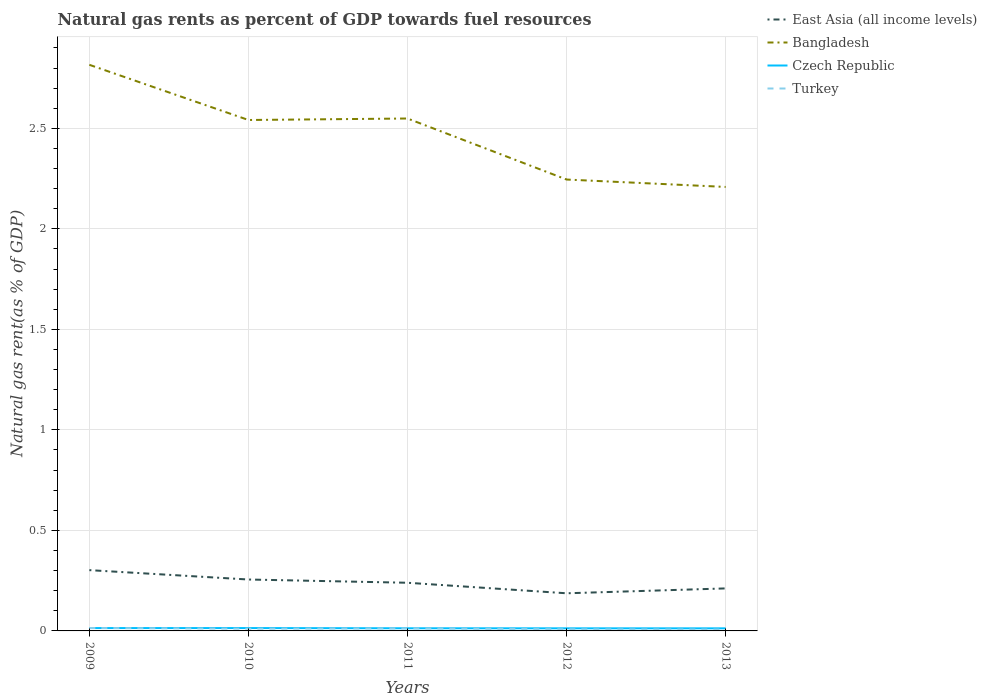Does the line corresponding to Turkey intersect with the line corresponding to Czech Republic?
Ensure brevity in your answer.  Yes. Across all years, what is the maximum natural gas rent in East Asia (all income levels)?
Make the answer very short. 0.19. In which year was the natural gas rent in East Asia (all income levels) maximum?
Your answer should be compact. 2012. What is the total natural gas rent in Czech Republic in the graph?
Ensure brevity in your answer.  0. What is the difference between the highest and the second highest natural gas rent in Bangladesh?
Provide a succinct answer. 0.61. What is the difference between the highest and the lowest natural gas rent in East Asia (all income levels)?
Provide a short and direct response. 3. Is the natural gas rent in Bangladesh strictly greater than the natural gas rent in East Asia (all income levels) over the years?
Your answer should be compact. No. What is the difference between two consecutive major ticks on the Y-axis?
Your answer should be compact. 0.5. Are the values on the major ticks of Y-axis written in scientific E-notation?
Give a very brief answer. No. How are the legend labels stacked?
Offer a terse response. Vertical. What is the title of the graph?
Make the answer very short. Natural gas rents as percent of GDP towards fuel resources. Does "Guinea" appear as one of the legend labels in the graph?
Offer a terse response. No. What is the label or title of the Y-axis?
Provide a succinct answer. Natural gas rent(as % of GDP). What is the Natural gas rent(as % of GDP) of East Asia (all income levels) in 2009?
Make the answer very short. 0.3. What is the Natural gas rent(as % of GDP) in Bangladesh in 2009?
Provide a succinct answer. 2.82. What is the Natural gas rent(as % of GDP) in Czech Republic in 2009?
Make the answer very short. 0.01. What is the Natural gas rent(as % of GDP) of Turkey in 2009?
Your answer should be compact. 0.01. What is the Natural gas rent(as % of GDP) of East Asia (all income levels) in 2010?
Give a very brief answer. 0.26. What is the Natural gas rent(as % of GDP) in Bangladesh in 2010?
Provide a short and direct response. 2.54. What is the Natural gas rent(as % of GDP) of Czech Republic in 2010?
Keep it short and to the point. 0.01. What is the Natural gas rent(as % of GDP) in Turkey in 2010?
Provide a short and direct response. 0.01. What is the Natural gas rent(as % of GDP) in East Asia (all income levels) in 2011?
Offer a very short reply. 0.24. What is the Natural gas rent(as % of GDP) of Bangladesh in 2011?
Give a very brief answer. 2.55. What is the Natural gas rent(as % of GDP) in Czech Republic in 2011?
Keep it short and to the point. 0.01. What is the Natural gas rent(as % of GDP) in Turkey in 2011?
Your response must be concise. 0.01. What is the Natural gas rent(as % of GDP) in East Asia (all income levels) in 2012?
Offer a terse response. 0.19. What is the Natural gas rent(as % of GDP) of Bangladesh in 2012?
Keep it short and to the point. 2.25. What is the Natural gas rent(as % of GDP) in Czech Republic in 2012?
Provide a short and direct response. 0.01. What is the Natural gas rent(as % of GDP) in Turkey in 2012?
Your response must be concise. 0.01. What is the Natural gas rent(as % of GDP) of East Asia (all income levels) in 2013?
Provide a short and direct response. 0.21. What is the Natural gas rent(as % of GDP) in Bangladesh in 2013?
Keep it short and to the point. 2.21. What is the Natural gas rent(as % of GDP) of Czech Republic in 2013?
Your answer should be compact. 0.01. What is the Natural gas rent(as % of GDP) of Turkey in 2013?
Provide a succinct answer. 0.01. Across all years, what is the maximum Natural gas rent(as % of GDP) in East Asia (all income levels)?
Keep it short and to the point. 0.3. Across all years, what is the maximum Natural gas rent(as % of GDP) of Bangladesh?
Your answer should be compact. 2.82. Across all years, what is the maximum Natural gas rent(as % of GDP) of Czech Republic?
Your answer should be very brief. 0.01. Across all years, what is the maximum Natural gas rent(as % of GDP) in Turkey?
Make the answer very short. 0.01. Across all years, what is the minimum Natural gas rent(as % of GDP) of East Asia (all income levels)?
Give a very brief answer. 0.19. Across all years, what is the minimum Natural gas rent(as % of GDP) of Bangladesh?
Provide a short and direct response. 2.21. Across all years, what is the minimum Natural gas rent(as % of GDP) of Czech Republic?
Provide a short and direct response. 0.01. Across all years, what is the minimum Natural gas rent(as % of GDP) in Turkey?
Keep it short and to the point. 0.01. What is the total Natural gas rent(as % of GDP) of East Asia (all income levels) in the graph?
Your response must be concise. 1.2. What is the total Natural gas rent(as % of GDP) of Bangladesh in the graph?
Provide a succinct answer. 12.36. What is the total Natural gas rent(as % of GDP) in Czech Republic in the graph?
Offer a very short reply. 0.07. What is the total Natural gas rent(as % of GDP) of Turkey in the graph?
Offer a terse response. 0.05. What is the difference between the Natural gas rent(as % of GDP) of East Asia (all income levels) in 2009 and that in 2010?
Keep it short and to the point. 0.05. What is the difference between the Natural gas rent(as % of GDP) in Bangladesh in 2009 and that in 2010?
Make the answer very short. 0.27. What is the difference between the Natural gas rent(as % of GDP) of Czech Republic in 2009 and that in 2010?
Your answer should be compact. -0. What is the difference between the Natural gas rent(as % of GDP) of Turkey in 2009 and that in 2010?
Offer a very short reply. 0. What is the difference between the Natural gas rent(as % of GDP) in East Asia (all income levels) in 2009 and that in 2011?
Your answer should be very brief. 0.06. What is the difference between the Natural gas rent(as % of GDP) in Bangladesh in 2009 and that in 2011?
Ensure brevity in your answer.  0.27. What is the difference between the Natural gas rent(as % of GDP) in Turkey in 2009 and that in 2011?
Provide a succinct answer. 0. What is the difference between the Natural gas rent(as % of GDP) of East Asia (all income levels) in 2009 and that in 2012?
Give a very brief answer. 0.12. What is the difference between the Natural gas rent(as % of GDP) of Bangladesh in 2009 and that in 2012?
Keep it short and to the point. 0.57. What is the difference between the Natural gas rent(as % of GDP) of Czech Republic in 2009 and that in 2012?
Offer a very short reply. 0. What is the difference between the Natural gas rent(as % of GDP) in Turkey in 2009 and that in 2012?
Your answer should be very brief. 0.01. What is the difference between the Natural gas rent(as % of GDP) of East Asia (all income levels) in 2009 and that in 2013?
Keep it short and to the point. 0.09. What is the difference between the Natural gas rent(as % of GDP) of Bangladesh in 2009 and that in 2013?
Give a very brief answer. 0.61. What is the difference between the Natural gas rent(as % of GDP) of Czech Republic in 2009 and that in 2013?
Ensure brevity in your answer.  0. What is the difference between the Natural gas rent(as % of GDP) in Turkey in 2009 and that in 2013?
Your response must be concise. 0.01. What is the difference between the Natural gas rent(as % of GDP) in East Asia (all income levels) in 2010 and that in 2011?
Your answer should be very brief. 0.02. What is the difference between the Natural gas rent(as % of GDP) in Bangladesh in 2010 and that in 2011?
Offer a terse response. -0.01. What is the difference between the Natural gas rent(as % of GDP) in Turkey in 2010 and that in 2011?
Offer a very short reply. -0. What is the difference between the Natural gas rent(as % of GDP) in East Asia (all income levels) in 2010 and that in 2012?
Keep it short and to the point. 0.07. What is the difference between the Natural gas rent(as % of GDP) of Bangladesh in 2010 and that in 2012?
Provide a succinct answer. 0.3. What is the difference between the Natural gas rent(as % of GDP) of Czech Republic in 2010 and that in 2012?
Your response must be concise. 0. What is the difference between the Natural gas rent(as % of GDP) in Turkey in 2010 and that in 2012?
Your response must be concise. 0. What is the difference between the Natural gas rent(as % of GDP) in East Asia (all income levels) in 2010 and that in 2013?
Your response must be concise. 0.04. What is the difference between the Natural gas rent(as % of GDP) of Bangladesh in 2010 and that in 2013?
Offer a terse response. 0.33. What is the difference between the Natural gas rent(as % of GDP) of Czech Republic in 2010 and that in 2013?
Your answer should be very brief. 0. What is the difference between the Natural gas rent(as % of GDP) of Turkey in 2010 and that in 2013?
Make the answer very short. 0. What is the difference between the Natural gas rent(as % of GDP) in East Asia (all income levels) in 2011 and that in 2012?
Your answer should be very brief. 0.05. What is the difference between the Natural gas rent(as % of GDP) in Bangladesh in 2011 and that in 2012?
Your answer should be compact. 0.3. What is the difference between the Natural gas rent(as % of GDP) of Turkey in 2011 and that in 2012?
Offer a terse response. 0. What is the difference between the Natural gas rent(as % of GDP) of East Asia (all income levels) in 2011 and that in 2013?
Make the answer very short. 0.03. What is the difference between the Natural gas rent(as % of GDP) in Bangladesh in 2011 and that in 2013?
Make the answer very short. 0.34. What is the difference between the Natural gas rent(as % of GDP) in Czech Republic in 2011 and that in 2013?
Make the answer very short. 0. What is the difference between the Natural gas rent(as % of GDP) in Turkey in 2011 and that in 2013?
Provide a short and direct response. 0.01. What is the difference between the Natural gas rent(as % of GDP) in East Asia (all income levels) in 2012 and that in 2013?
Your answer should be compact. -0.02. What is the difference between the Natural gas rent(as % of GDP) of Bangladesh in 2012 and that in 2013?
Offer a very short reply. 0.04. What is the difference between the Natural gas rent(as % of GDP) of Czech Republic in 2012 and that in 2013?
Keep it short and to the point. 0. What is the difference between the Natural gas rent(as % of GDP) in Turkey in 2012 and that in 2013?
Provide a succinct answer. 0. What is the difference between the Natural gas rent(as % of GDP) in East Asia (all income levels) in 2009 and the Natural gas rent(as % of GDP) in Bangladesh in 2010?
Ensure brevity in your answer.  -2.24. What is the difference between the Natural gas rent(as % of GDP) of East Asia (all income levels) in 2009 and the Natural gas rent(as % of GDP) of Czech Republic in 2010?
Your answer should be very brief. 0.29. What is the difference between the Natural gas rent(as % of GDP) of East Asia (all income levels) in 2009 and the Natural gas rent(as % of GDP) of Turkey in 2010?
Offer a very short reply. 0.29. What is the difference between the Natural gas rent(as % of GDP) in Bangladesh in 2009 and the Natural gas rent(as % of GDP) in Czech Republic in 2010?
Ensure brevity in your answer.  2.8. What is the difference between the Natural gas rent(as % of GDP) in Bangladesh in 2009 and the Natural gas rent(as % of GDP) in Turkey in 2010?
Keep it short and to the point. 2.81. What is the difference between the Natural gas rent(as % of GDP) in Czech Republic in 2009 and the Natural gas rent(as % of GDP) in Turkey in 2010?
Your answer should be very brief. 0. What is the difference between the Natural gas rent(as % of GDP) of East Asia (all income levels) in 2009 and the Natural gas rent(as % of GDP) of Bangladesh in 2011?
Offer a very short reply. -2.25. What is the difference between the Natural gas rent(as % of GDP) in East Asia (all income levels) in 2009 and the Natural gas rent(as % of GDP) in Czech Republic in 2011?
Your answer should be very brief. 0.29. What is the difference between the Natural gas rent(as % of GDP) of East Asia (all income levels) in 2009 and the Natural gas rent(as % of GDP) of Turkey in 2011?
Your answer should be very brief. 0.29. What is the difference between the Natural gas rent(as % of GDP) of Bangladesh in 2009 and the Natural gas rent(as % of GDP) of Czech Republic in 2011?
Give a very brief answer. 2.8. What is the difference between the Natural gas rent(as % of GDP) of Bangladesh in 2009 and the Natural gas rent(as % of GDP) of Turkey in 2011?
Offer a very short reply. 2.8. What is the difference between the Natural gas rent(as % of GDP) of Czech Republic in 2009 and the Natural gas rent(as % of GDP) of Turkey in 2011?
Keep it short and to the point. 0. What is the difference between the Natural gas rent(as % of GDP) in East Asia (all income levels) in 2009 and the Natural gas rent(as % of GDP) in Bangladesh in 2012?
Provide a succinct answer. -1.94. What is the difference between the Natural gas rent(as % of GDP) in East Asia (all income levels) in 2009 and the Natural gas rent(as % of GDP) in Czech Republic in 2012?
Provide a short and direct response. 0.29. What is the difference between the Natural gas rent(as % of GDP) of East Asia (all income levels) in 2009 and the Natural gas rent(as % of GDP) of Turkey in 2012?
Your answer should be very brief. 0.29. What is the difference between the Natural gas rent(as % of GDP) of Bangladesh in 2009 and the Natural gas rent(as % of GDP) of Czech Republic in 2012?
Your answer should be very brief. 2.8. What is the difference between the Natural gas rent(as % of GDP) in Bangladesh in 2009 and the Natural gas rent(as % of GDP) in Turkey in 2012?
Make the answer very short. 2.81. What is the difference between the Natural gas rent(as % of GDP) in Czech Republic in 2009 and the Natural gas rent(as % of GDP) in Turkey in 2012?
Provide a succinct answer. 0.01. What is the difference between the Natural gas rent(as % of GDP) in East Asia (all income levels) in 2009 and the Natural gas rent(as % of GDP) in Bangladesh in 2013?
Provide a succinct answer. -1.91. What is the difference between the Natural gas rent(as % of GDP) in East Asia (all income levels) in 2009 and the Natural gas rent(as % of GDP) in Czech Republic in 2013?
Provide a short and direct response. 0.29. What is the difference between the Natural gas rent(as % of GDP) of East Asia (all income levels) in 2009 and the Natural gas rent(as % of GDP) of Turkey in 2013?
Provide a short and direct response. 0.3. What is the difference between the Natural gas rent(as % of GDP) in Bangladesh in 2009 and the Natural gas rent(as % of GDP) in Czech Republic in 2013?
Your response must be concise. 2.8. What is the difference between the Natural gas rent(as % of GDP) in Bangladesh in 2009 and the Natural gas rent(as % of GDP) in Turkey in 2013?
Ensure brevity in your answer.  2.81. What is the difference between the Natural gas rent(as % of GDP) in Czech Republic in 2009 and the Natural gas rent(as % of GDP) in Turkey in 2013?
Make the answer very short. 0.01. What is the difference between the Natural gas rent(as % of GDP) of East Asia (all income levels) in 2010 and the Natural gas rent(as % of GDP) of Bangladesh in 2011?
Give a very brief answer. -2.29. What is the difference between the Natural gas rent(as % of GDP) in East Asia (all income levels) in 2010 and the Natural gas rent(as % of GDP) in Czech Republic in 2011?
Provide a succinct answer. 0.24. What is the difference between the Natural gas rent(as % of GDP) of East Asia (all income levels) in 2010 and the Natural gas rent(as % of GDP) of Turkey in 2011?
Your answer should be very brief. 0.24. What is the difference between the Natural gas rent(as % of GDP) in Bangladesh in 2010 and the Natural gas rent(as % of GDP) in Czech Republic in 2011?
Offer a terse response. 2.53. What is the difference between the Natural gas rent(as % of GDP) in Bangladesh in 2010 and the Natural gas rent(as % of GDP) in Turkey in 2011?
Ensure brevity in your answer.  2.53. What is the difference between the Natural gas rent(as % of GDP) of Czech Republic in 2010 and the Natural gas rent(as % of GDP) of Turkey in 2011?
Offer a terse response. 0. What is the difference between the Natural gas rent(as % of GDP) in East Asia (all income levels) in 2010 and the Natural gas rent(as % of GDP) in Bangladesh in 2012?
Offer a terse response. -1.99. What is the difference between the Natural gas rent(as % of GDP) of East Asia (all income levels) in 2010 and the Natural gas rent(as % of GDP) of Czech Republic in 2012?
Offer a terse response. 0.24. What is the difference between the Natural gas rent(as % of GDP) in East Asia (all income levels) in 2010 and the Natural gas rent(as % of GDP) in Turkey in 2012?
Make the answer very short. 0.25. What is the difference between the Natural gas rent(as % of GDP) in Bangladesh in 2010 and the Natural gas rent(as % of GDP) in Czech Republic in 2012?
Offer a terse response. 2.53. What is the difference between the Natural gas rent(as % of GDP) of Bangladesh in 2010 and the Natural gas rent(as % of GDP) of Turkey in 2012?
Keep it short and to the point. 2.53. What is the difference between the Natural gas rent(as % of GDP) of Czech Republic in 2010 and the Natural gas rent(as % of GDP) of Turkey in 2012?
Offer a very short reply. 0.01. What is the difference between the Natural gas rent(as % of GDP) in East Asia (all income levels) in 2010 and the Natural gas rent(as % of GDP) in Bangladesh in 2013?
Offer a terse response. -1.95. What is the difference between the Natural gas rent(as % of GDP) of East Asia (all income levels) in 2010 and the Natural gas rent(as % of GDP) of Czech Republic in 2013?
Make the answer very short. 0.24. What is the difference between the Natural gas rent(as % of GDP) in East Asia (all income levels) in 2010 and the Natural gas rent(as % of GDP) in Turkey in 2013?
Your response must be concise. 0.25. What is the difference between the Natural gas rent(as % of GDP) of Bangladesh in 2010 and the Natural gas rent(as % of GDP) of Czech Republic in 2013?
Your answer should be very brief. 2.53. What is the difference between the Natural gas rent(as % of GDP) of Bangladesh in 2010 and the Natural gas rent(as % of GDP) of Turkey in 2013?
Offer a very short reply. 2.53. What is the difference between the Natural gas rent(as % of GDP) in Czech Republic in 2010 and the Natural gas rent(as % of GDP) in Turkey in 2013?
Provide a short and direct response. 0.01. What is the difference between the Natural gas rent(as % of GDP) in East Asia (all income levels) in 2011 and the Natural gas rent(as % of GDP) in Bangladesh in 2012?
Make the answer very short. -2.01. What is the difference between the Natural gas rent(as % of GDP) of East Asia (all income levels) in 2011 and the Natural gas rent(as % of GDP) of Czech Republic in 2012?
Offer a terse response. 0.23. What is the difference between the Natural gas rent(as % of GDP) in East Asia (all income levels) in 2011 and the Natural gas rent(as % of GDP) in Turkey in 2012?
Keep it short and to the point. 0.23. What is the difference between the Natural gas rent(as % of GDP) in Bangladesh in 2011 and the Natural gas rent(as % of GDP) in Czech Republic in 2012?
Offer a very short reply. 2.54. What is the difference between the Natural gas rent(as % of GDP) in Bangladesh in 2011 and the Natural gas rent(as % of GDP) in Turkey in 2012?
Provide a short and direct response. 2.54. What is the difference between the Natural gas rent(as % of GDP) in Czech Republic in 2011 and the Natural gas rent(as % of GDP) in Turkey in 2012?
Your answer should be compact. 0.01. What is the difference between the Natural gas rent(as % of GDP) of East Asia (all income levels) in 2011 and the Natural gas rent(as % of GDP) of Bangladesh in 2013?
Provide a short and direct response. -1.97. What is the difference between the Natural gas rent(as % of GDP) of East Asia (all income levels) in 2011 and the Natural gas rent(as % of GDP) of Czech Republic in 2013?
Ensure brevity in your answer.  0.23. What is the difference between the Natural gas rent(as % of GDP) in East Asia (all income levels) in 2011 and the Natural gas rent(as % of GDP) in Turkey in 2013?
Give a very brief answer. 0.23. What is the difference between the Natural gas rent(as % of GDP) in Bangladesh in 2011 and the Natural gas rent(as % of GDP) in Czech Republic in 2013?
Your answer should be very brief. 2.54. What is the difference between the Natural gas rent(as % of GDP) in Bangladesh in 2011 and the Natural gas rent(as % of GDP) in Turkey in 2013?
Offer a very short reply. 2.54. What is the difference between the Natural gas rent(as % of GDP) of Czech Republic in 2011 and the Natural gas rent(as % of GDP) of Turkey in 2013?
Make the answer very short. 0.01. What is the difference between the Natural gas rent(as % of GDP) in East Asia (all income levels) in 2012 and the Natural gas rent(as % of GDP) in Bangladesh in 2013?
Your answer should be compact. -2.02. What is the difference between the Natural gas rent(as % of GDP) in East Asia (all income levels) in 2012 and the Natural gas rent(as % of GDP) in Czech Republic in 2013?
Provide a short and direct response. 0.17. What is the difference between the Natural gas rent(as % of GDP) of East Asia (all income levels) in 2012 and the Natural gas rent(as % of GDP) of Turkey in 2013?
Keep it short and to the point. 0.18. What is the difference between the Natural gas rent(as % of GDP) in Bangladesh in 2012 and the Natural gas rent(as % of GDP) in Czech Republic in 2013?
Provide a succinct answer. 2.23. What is the difference between the Natural gas rent(as % of GDP) of Bangladesh in 2012 and the Natural gas rent(as % of GDP) of Turkey in 2013?
Offer a terse response. 2.24. What is the difference between the Natural gas rent(as % of GDP) in Czech Republic in 2012 and the Natural gas rent(as % of GDP) in Turkey in 2013?
Your response must be concise. 0.01. What is the average Natural gas rent(as % of GDP) of East Asia (all income levels) per year?
Make the answer very short. 0.24. What is the average Natural gas rent(as % of GDP) in Bangladesh per year?
Offer a terse response. 2.47. What is the average Natural gas rent(as % of GDP) of Czech Republic per year?
Offer a terse response. 0.01. What is the average Natural gas rent(as % of GDP) of Turkey per year?
Your response must be concise. 0.01. In the year 2009, what is the difference between the Natural gas rent(as % of GDP) of East Asia (all income levels) and Natural gas rent(as % of GDP) of Bangladesh?
Your answer should be compact. -2.51. In the year 2009, what is the difference between the Natural gas rent(as % of GDP) of East Asia (all income levels) and Natural gas rent(as % of GDP) of Czech Republic?
Your answer should be compact. 0.29. In the year 2009, what is the difference between the Natural gas rent(as % of GDP) in East Asia (all income levels) and Natural gas rent(as % of GDP) in Turkey?
Offer a very short reply. 0.29. In the year 2009, what is the difference between the Natural gas rent(as % of GDP) of Bangladesh and Natural gas rent(as % of GDP) of Czech Republic?
Offer a terse response. 2.8. In the year 2009, what is the difference between the Natural gas rent(as % of GDP) of Bangladesh and Natural gas rent(as % of GDP) of Turkey?
Provide a succinct answer. 2.8. In the year 2009, what is the difference between the Natural gas rent(as % of GDP) of Czech Republic and Natural gas rent(as % of GDP) of Turkey?
Offer a terse response. -0. In the year 2010, what is the difference between the Natural gas rent(as % of GDP) of East Asia (all income levels) and Natural gas rent(as % of GDP) of Bangladesh?
Your response must be concise. -2.29. In the year 2010, what is the difference between the Natural gas rent(as % of GDP) of East Asia (all income levels) and Natural gas rent(as % of GDP) of Czech Republic?
Ensure brevity in your answer.  0.24. In the year 2010, what is the difference between the Natural gas rent(as % of GDP) of East Asia (all income levels) and Natural gas rent(as % of GDP) of Turkey?
Your answer should be very brief. 0.24. In the year 2010, what is the difference between the Natural gas rent(as % of GDP) in Bangladesh and Natural gas rent(as % of GDP) in Czech Republic?
Make the answer very short. 2.53. In the year 2010, what is the difference between the Natural gas rent(as % of GDP) of Bangladesh and Natural gas rent(as % of GDP) of Turkey?
Your answer should be very brief. 2.53. In the year 2010, what is the difference between the Natural gas rent(as % of GDP) of Czech Republic and Natural gas rent(as % of GDP) of Turkey?
Offer a terse response. 0. In the year 2011, what is the difference between the Natural gas rent(as % of GDP) in East Asia (all income levels) and Natural gas rent(as % of GDP) in Bangladesh?
Provide a short and direct response. -2.31. In the year 2011, what is the difference between the Natural gas rent(as % of GDP) of East Asia (all income levels) and Natural gas rent(as % of GDP) of Czech Republic?
Give a very brief answer. 0.23. In the year 2011, what is the difference between the Natural gas rent(as % of GDP) of East Asia (all income levels) and Natural gas rent(as % of GDP) of Turkey?
Provide a succinct answer. 0.23. In the year 2011, what is the difference between the Natural gas rent(as % of GDP) of Bangladesh and Natural gas rent(as % of GDP) of Czech Republic?
Provide a short and direct response. 2.54. In the year 2011, what is the difference between the Natural gas rent(as % of GDP) of Bangladesh and Natural gas rent(as % of GDP) of Turkey?
Offer a very short reply. 2.54. In the year 2011, what is the difference between the Natural gas rent(as % of GDP) in Czech Republic and Natural gas rent(as % of GDP) in Turkey?
Keep it short and to the point. 0. In the year 2012, what is the difference between the Natural gas rent(as % of GDP) of East Asia (all income levels) and Natural gas rent(as % of GDP) of Bangladesh?
Provide a short and direct response. -2.06. In the year 2012, what is the difference between the Natural gas rent(as % of GDP) of East Asia (all income levels) and Natural gas rent(as % of GDP) of Czech Republic?
Your answer should be very brief. 0.17. In the year 2012, what is the difference between the Natural gas rent(as % of GDP) in East Asia (all income levels) and Natural gas rent(as % of GDP) in Turkey?
Your response must be concise. 0.18. In the year 2012, what is the difference between the Natural gas rent(as % of GDP) of Bangladesh and Natural gas rent(as % of GDP) of Czech Republic?
Give a very brief answer. 2.23. In the year 2012, what is the difference between the Natural gas rent(as % of GDP) in Bangladesh and Natural gas rent(as % of GDP) in Turkey?
Your answer should be very brief. 2.24. In the year 2012, what is the difference between the Natural gas rent(as % of GDP) in Czech Republic and Natural gas rent(as % of GDP) in Turkey?
Provide a short and direct response. 0. In the year 2013, what is the difference between the Natural gas rent(as % of GDP) in East Asia (all income levels) and Natural gas rent(as % of GDP) in Bangladesh?
Provide a short and direct response. -2. In the year 2013, what is the difference between the Natural gas rent(as % of GDP) in East Asia (all income levels) and Natural gas rent(as % of GDP) in Czech Republic?
Provide a short and direct response. 0.2. In the year 2013, what is the difference between the Natural gas rent(as % of GDP) in East Asia (all income levels) and Natural gas rent(as % of GDP) in Turkey?
Offer a terse response. 0.2. In the year 2013, what is the difference between the Natural gas rent(as % of GDP) in Bangladesh and Natural gas rent(as % of GDP) in Czech Republic?
Ensure brevity in your answer.  2.2. In the year 2013, what is the difference between the Natural gas rent(as % of GDP) in Bangladesh and Natural gas rent(as % of GDP) in Turkey?
Your answer should be compact. 2.2. In the year 2013, what is the difference between the Natural gas rent(as % of GDP) of Czech Republic and Natural gas rent(as % of GDP) of Turkey?
Give a very brief answer. 0.01. What is the ratio of the Natural gas rent(as % of GDP) in East Asia (all income levels) in 2009 to that in 2010?
Your answer should be very brief. 1.18. What is the ratio of the Natural gas rent(as % of GDP) of Bangladesh in 2009 to that in 2010?
Provide a succinct answer. 1.11. What is the ratio of the Natural gas rent(as % of GDP) in Czech Republic in 2009 to that in 2010?
Offer a very short reply. 1. What is the ratio of the Natural gas rent(as % of GDP) of Turkey in 2009 to that in 2010?
Offer a terse response. 1.31. What is the ratio of the Natural gas rent(as % of GDP) in East Asia (all income levels) in 2009 to that in 2011?
Your answer should be very brief. 1.26. What is the ratio of the Natural gas rent(as % of GDP) of Bangladesh in 2009 to that in 2011?
Offer a terse response. 1.1. What is the ratio of the Natural gas rent(as % of GDP) of Czech Republic in 2009 to that in 2011?
Your answer should be very brief. 1.08. What is the ratio of the Natural gas rent(as % of GDP) of Turkey in 2009 to that in 2011?
Give a very brief answer. 1.15. What is the ratio of the Natural gas rent(as % of GDP) in East Asia (all income levels) in 2009 to that in 2012?
Ensure brevity in your answer.  1.62. What is the ratio of the Natural gas rent(as % of GDP) in Bangladesh in 2009 to that in 2012?
Keep it short and to the point. 1.25. What is the ratio of the Natural gas rent(as % of GDP) in Czech Republic in 2009 to that in 2012?
Provide a succinct answer. 1.1. What is the ratio of the Natural gas rent(as % of GDP) in Turkey in 2009 to that in 2012?
Offer a very short reply. 1.79. What is the ratio of the Natural gas rent(as % of GDP) in East Asia (all income levels) in 2009 to that in 2013?
Give a very brief answer. 1.43. What is the ratio of the Natural gas rent(as % of GDP) in Bangladesh in 2009 to that in 2013?
Offer a terse response. 1.28. What is the ratio of the Natural gas rent(as % of GDP) in Czech Republic in 2009 to that in 2013?
Your response must be concise. 1.11. What is the ratio of the Natural gas rent(as % of GDP) in Turkey in 2009 to that in 2013?
Your answer should be compact. 2.11. What is the ratio of the Natural gas rent(as % of GDP) of East Asia (all income levels) in 2010 to that in 2011?
Provide a succinct answer. 1.07. What is the ratio of the Natural gas rent(as % of GDP) in Czech Republic in 2010 to that in 2011?
Keep it short and to the point. 1.08. What is the ratio of the Natural gas rent(as % of GDP) of Turkey in 2010 to that in 2011?
Make the answer very short. 0.88. What is the ratio of the Natural gas rent(as % of GDP) in East Asia (all income levels) in 2010 to that in 2012?
Your answer should be very brief. 1.37. What is the ratio of the Natural gas rent(as % of GDP) of Bangladesh in 2010 to that in 2012?
Provide a succinct answer. 1.13. What is the ratio of the Natural gas rent(as % of GDP) in Czech Republic in 2010 to that in 2012?
Your response must be concise. 1.1. What is the ratio of the Natural gas rent(as % of GDP) in Turkey in 2010 to that in 2012?
Keep it short and to the point. 1.36. What is the ratio of the Natural gas rent(as % of GDP) of East Asia (all income levels) in 2010 to that in 2013?
Give a very brief answer. 1.21. What is the ratio of the Natural gas rent(as % of GDP) of Bangladesh in 2010 to that in 2013?
Make the answer very short. 1.15. What is the ratio of the Natural gas rent(as % of GDP) in Czech Republic in 2010 to that in 2013?
Keep it short and to the point. 1.11. What is the ratio of the Natural gas rent(as % of GDP) of Turkey in 2010 to that in 2013?
Make the answer very short. 1.6. What is the ratio of the Natural gas rent(as % of GDP) of East Asia (all income levels) in 2011 to that in 2012?
Offer a very short reply. 1.28. What is the ratio of the Natural gas rent(as % of GDP) of Bangladesh in 2011 to that in 2012?
Your answer should be compact. 1.14. What is the ratio of the Natural gas rent(as % of GDP) in Czech Republic in 2011 to that in 2012?
Keep it short and to the point. 1.02. What is the ratio of the Natural gas rent(as % of GDP) in Turkey in 2011 to that in 2012?
Your answer should be compact. 1.55. What is the ratio of the Natural gas rent(as % of GDP) in East Asia (all income levels) in 2011 to that in 2013?
Keep it short and to the point. 1.13. What is the ratio of the Natural gas rent(as % of GDP) of Bangladesh in 2011 to that in 2013?
Offer a very short reply. 1.15. What is the ratio of the Natural gas rent(as % of GDP) of Czech Republic in 2011 to that in 2013?
Keep it short and to the point. 1.03. What is the ratio of the Natural gas rent(as % of GDP) of Turkey in 2011 to that in 2013?
Your answer should be compact. 1.83. What is the ratio of the Natural gas rent(as % of GDP) of East Asia (all income levels) in 2012 to that in 2013?
Ensure brevity in your answer.  0.89. What is the ratio of the Natural gas rent(as % of GDP) in Bangladesh in 2012 to that in 2013?
Your response must be concise. 1.02. What is the ratio of the Natural gas rent(as % of GDP) of Czech Republic in 2012 to that in 2013?
Give a very brief answer. 1.01. What is the ratio of the Natural gas rent(as % of GDP) in Turkey in 2012 to that in 2013?
Keep it short and to the point. 1.18. What is the difference between the highest and the second highest Natural gas rent(as % of GDP) in East Asia (all income levels)?
Make the answer very short. 0.05. What is the difference between the highest and the second highest Natural gas rent(as % of GDP) in Bangladesh?
Offer a terse response. 0.27. What is the difference between the highest and the second highest Natural gas rent(as % of GDP) of Czech Republic?
Provide a short and direct response. 0. What is the difference between the highest and the second highest Natural gas rent(as % of GDP) in Turkey?
Offer a terse response. 0. What is the difference between the highest and the lowest Natural gas rent(as % of GDP) in East Asia (all income levels)?
Provide a succinct answer. 0.12. What is the difference between the highest and the lowest Natural gas rent(as % of GDP) of Bangladesh?
Your answer should be compact. 0.61. What is the difference between the highest and the lowest Natural gas rent(as % of GDP) in Czech Republic?
Keep it short and to the point. 0. What is the difference between the highest and the lowest Natural gas rent(as % of GDP) in Turkey?
Make the answer very short. 0.01. 